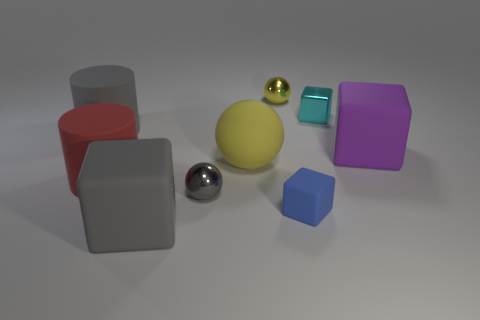Subtract 1 cubes. How many cubes are left? 3 Subtract all red cylinders. Subtract all purple blocks. How many cylinders are left? 1 Add 1 tiny cyan things. How many objects exist? 10 Subtract all spheres. How many objects are left? 6 Add 4 gray things. How many gray things are left? 7 Add 1 blue cubes. How many blue cubes exist? 2 Subtract 0 purple balls. How many objects are left? 9 Subtract all red rubber cylinders. Subtract all yellow rubber things. How many objects are left? 7 